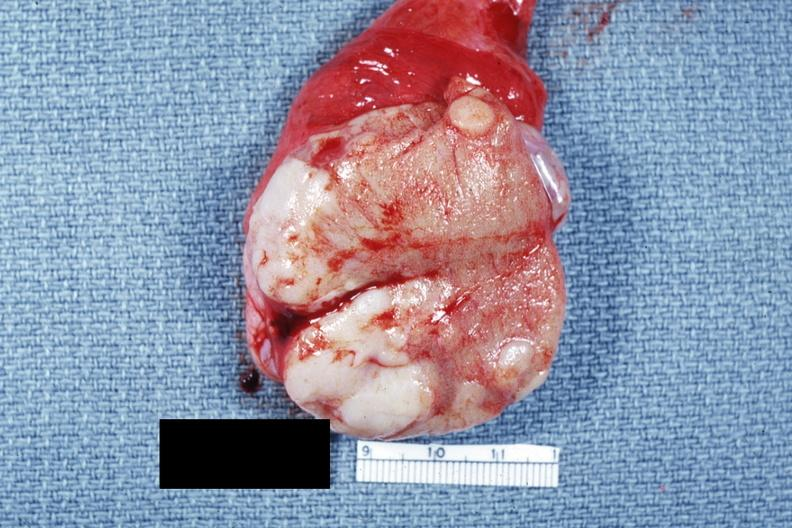what is present?
Answer the question using a single word or phrase. Metastatic carcinoma 